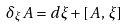<formula> <loc_0><loc_0><loc_500><loc_500>\delta _ { \xi } A = d \xi + \left [ A \, , \, \xi \right ]</formula> 